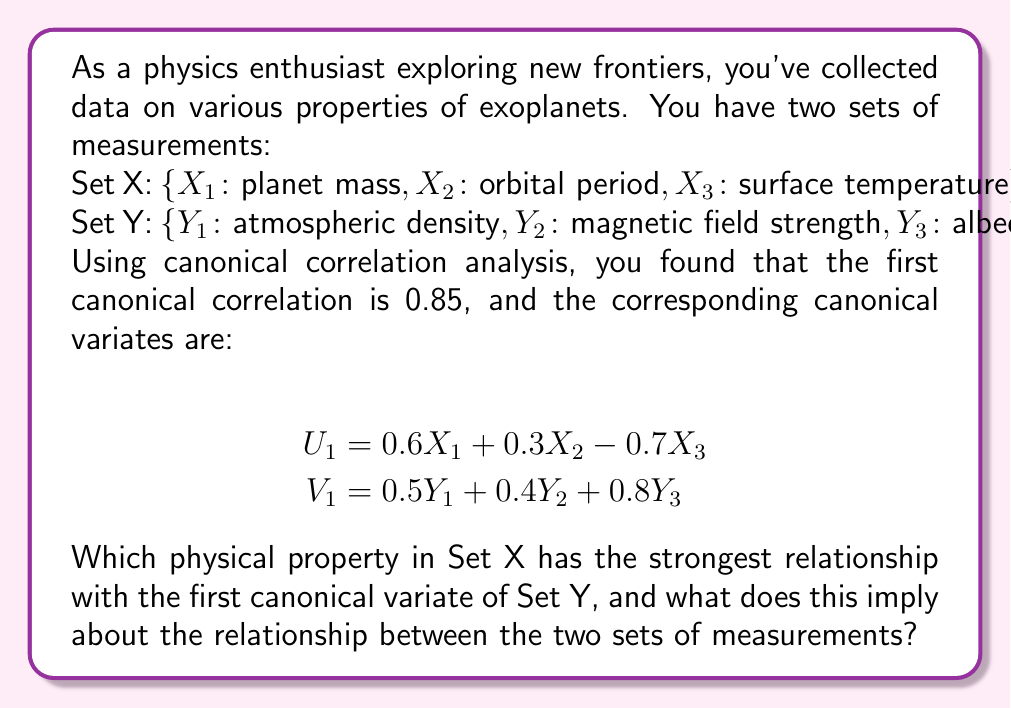Give your solution to this math problem. To solve this problem, we need to understand the interpretation of canonical correlation analysis (CCA) and the meaning of canonical variates.

1. CCA finds linear combinations of variables in two sets that have maximum correlation with each other. These linear combinations are called canonical variates.

2. The coefficients of the canonical variates (canonical weights) indicate the relative importance of each variable in the linear combination.

3. The absolute value of these coefficients can be used to determine which variables contribute most strongly to the relationship between the two sets.

4. In this case, we're given the first canonical variates:
   $U_1 = 0.6X_1 + 0.3X_2 - 0.7X_3$
   $V_1 = 0.5Y_1 + 0.4Y_2 + 0.8Y_3$

5. To determine which property in Set X has the strongest relationship with the first canonical variate of Set Y ($V_1$), we need to look at the absolute values of the coefficients in $U_1$:
   
   $|0.6|$ for $X_1$ (mass)
   $|0.3|$ for $X_2$ (orbital period)
   $|-0.7|$ = $0.7$ for $X_3$ (surface temperature)

6. The largest absolute value is 0.7, corresponding to $X_3$ (surface temperature).

7. This implies that surface temperature has the strongest relationship with the first canonical variate of Set Y.

8. The negative sign (-0.7) indicates an inverse relationship: as surface temperature increases, the value of $V_1$ tends to decrease.

9. Looking at $V_1$, we see that albedo ($Y_3$) has the largest coefficient (0.8). This suggests that surface temperature is most strongly related to albedo, with an inverse relationship.

10. The high canonical correlation (0.85) indicates a strong overall relationship between these two sets of exoplanet properties.
Answer: Surface temperature ($X_3$) has the strongest relationship with the first canonical variate of Set Y. This implies an inverse relationship between surface temperature and the combination of atmospheric properties in Set Y, particularly albedo. The high canonical correlation (0.85) suggests a strong overall relationship between the planet's physical properties (mass, orbital period, surface temperature) and its atmospheric characteristics (density, magnetic field strength, albedo). 